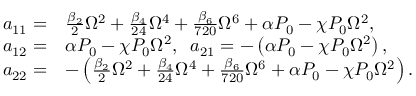<formula> <loc_0><loc_0><loc_500><loc_500>\begin{array} { r l } { a _ { 1 1 } = } & { \frac { \beta _ { 2 } } { 2 } \Omega ^ { 2 } + \frac { \beta _ { 4 } } { 2 4 } \Omega ^ { 4 } + \frac { \beta _ { 6 } } { 7 2 0 } \Omega ^ { 6 } + \alpha P _ { 0 } - \chi P _ { 0 } \Omega ^ { 2 } , } \\ { a _ { 1 2 } = } & { \alpha P _ { 0 } - \chi P _ { 0 } \Omega ^ { 2 } , \, a _ { 2 1 } = - \left ( \alpha P _ { 0 } - \chi P _ { 0 } \Omega ^ { 2 } \right ) , } \\ { a _ { 2 2 } = } & { - \left ( \frac { \beta _ { 2 } } { 2 } \Omega ^ { 2 } + \frac { \beta _ { 4 } } { 2 4 } \Omega ^ { 4 } + \frac { \beta _ { 6 } } { 7 2 0 } \Omega ^ { 6 } + \alpha P _ { 0 } - \chi P _ { 0 } \Omega ^ { 2 } \right ) . } \end{array}</formula> 